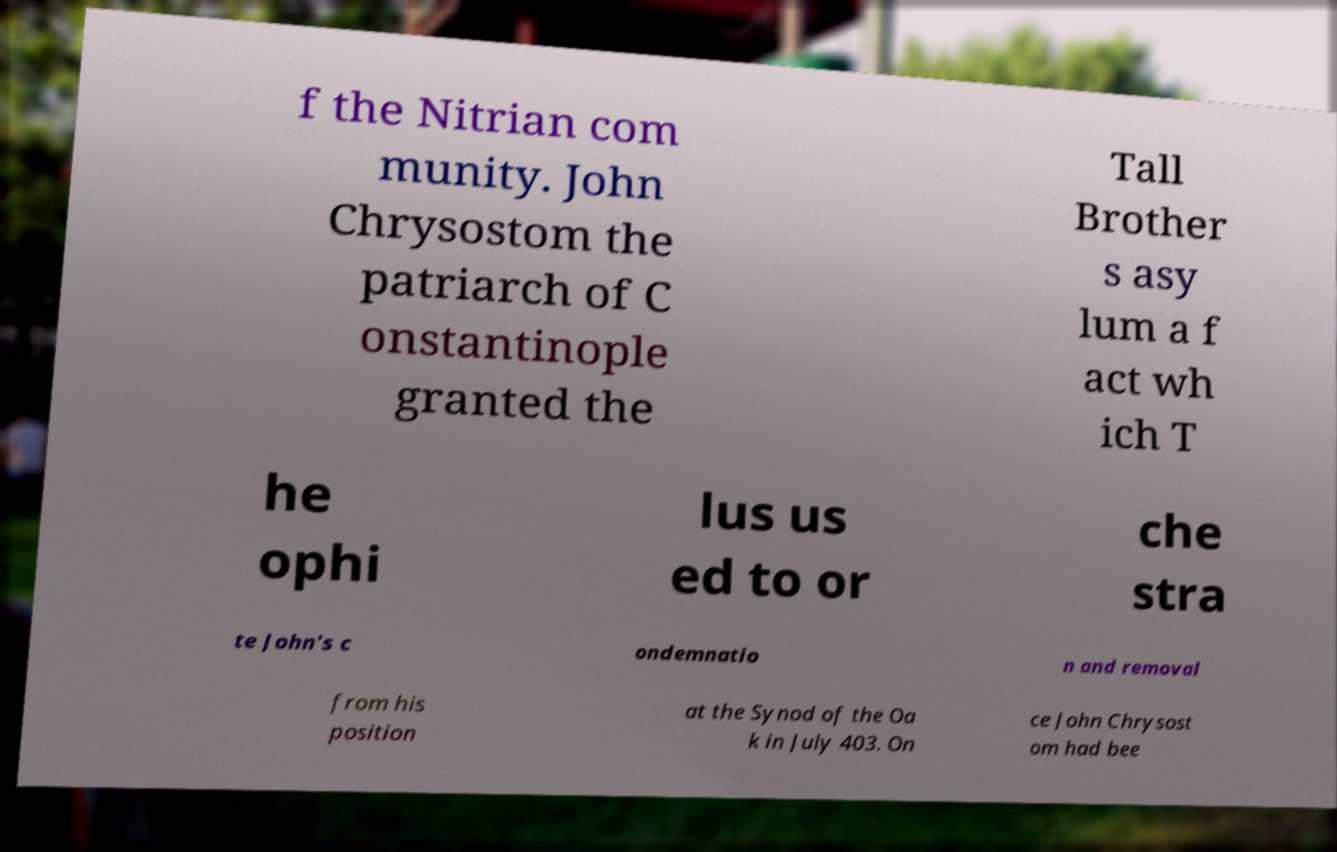For documentation purposes, I need the text within this image transcribed. Could you provide that? f the Nitrian com munity. John Chrysostom the patriarch of C onstantinople granted the Tall Brother s asy lum a f act wh ich T he ophi lus us ed to or che stra te John's c ondemnatio n and removal from his position at the Synod of the Oa k in July 403. On ce John Chrysost om had bee 